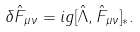Convert formula to latex. <formula><loc_0><loc_0><loc_500><loc_500>\delta \hat { F } _ { \mu \nu } = i g [ \hat { \Lambda } , \hat { F } _ { \mu \nu } ] _ { * } .</formula> 